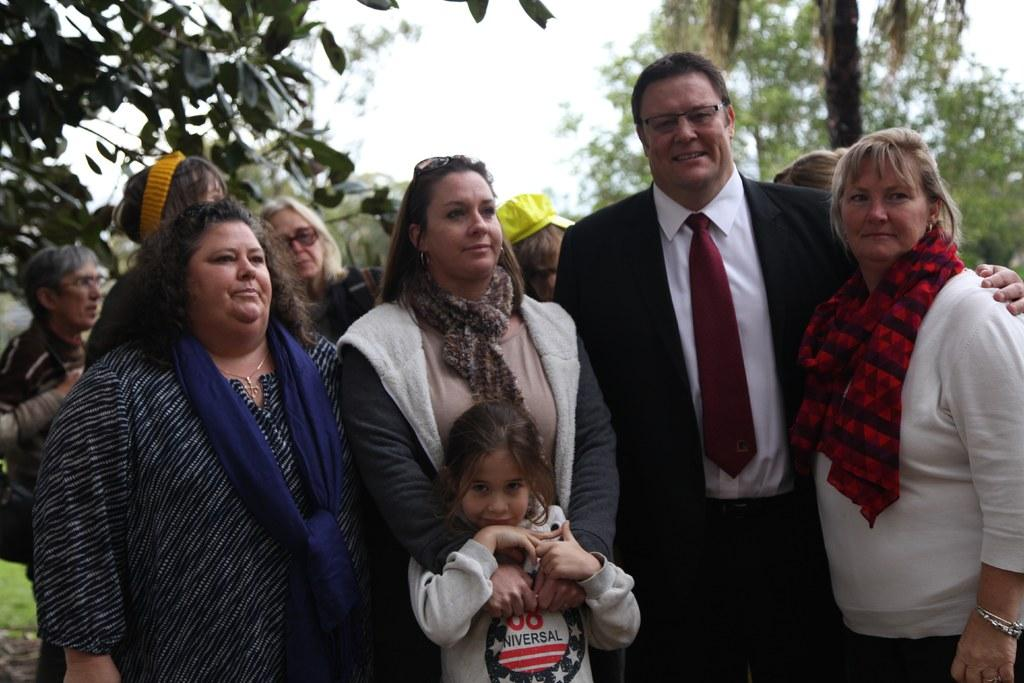What is happening in the image? There are people standing in the image. How would you describe the background of the image? The background of the image is slightly blurred. What can be seen in the distance in the image? There are trees and the sky visible in the background. Who is wearing the crown in the image? There is no crown present in the image. How many people are in the crowd in the image? There is no crowd present in the image; it features people standing in a group. 